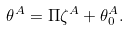Convert formula to latex. <formula><loc_0><loc_0><loc_500><loc_500>\theta ^ { A } = { \Pi } \zeta ^ { A } + \theta ^ { A } _ { 0 } .</formula> 